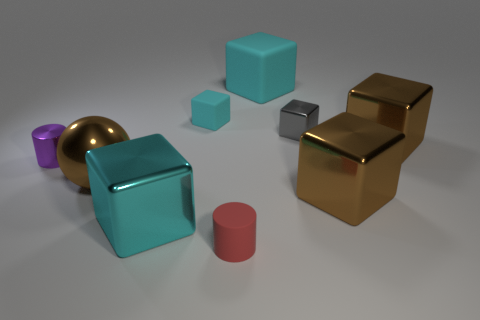Are there an equal number of cubes on the right side of the small red matte object and red matte blocks?
Your response must be concise. No. How many objects are either brown shiny cubes or cyan things in front of the purple shiny cylinder?
Your response must be concise. 3. Are there any brown metal things of the same shape as the tiny red matte object?
Ensure brevity in your answer.  No. Are there the same number of large objects left of the tiny metallic cylinder and red objects on the left side of the tiny gray metallic block?
Your answer should be very brief. No. What number of cyan objects are either big rubber cubes or small shiny things?
Ensure brevity in your answer.  1. How many blue matte balls have the same size as the cyan shiny object?
Give a very brief answer. 0. There is a big block that is both behind the brown ball and on the right side of the big matte thing; what is its color?
Your response must be concise. Brown. Are there more tiny rubber things that are behind the cyan metal block than cyan blocks?
Offer a terse response. No. Are there any brown objects?
Offer a terse response. Yes. Is the large metallic sphere the same color as the big rubber object?
Give a very brief answer. No. 